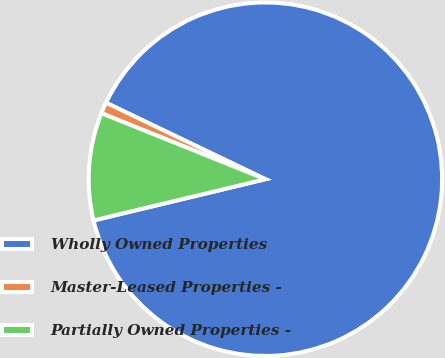Convert chart to OTSL. <chart><loc_0><loc_0><loc_500><loc_500><pie_chart><fcel>Wholly Owned Properties<fcel>Master-Leased Properties -<fcel>Partially Owned Properties -<nl><fcel>89.12%<fcel>1.03%<fcel>9.84%<nl></chart> 